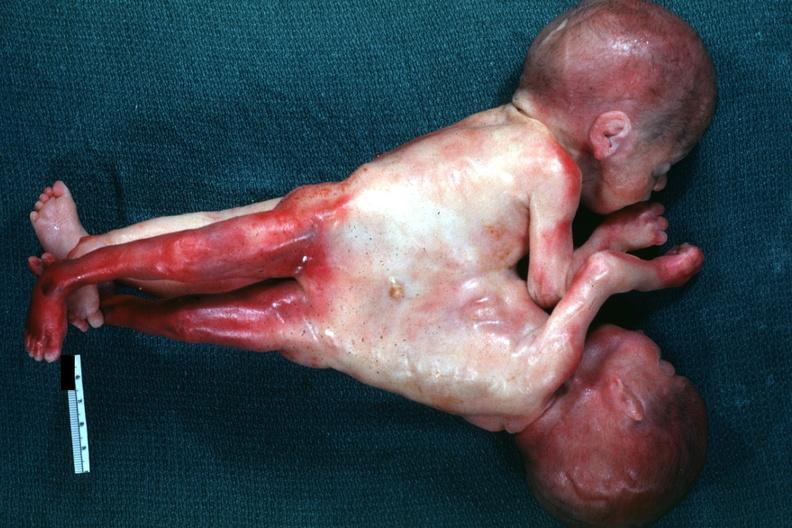what does this image show?
Answer the question using a single word or phrase. Very good example joined abdomen and lower chest anterior 